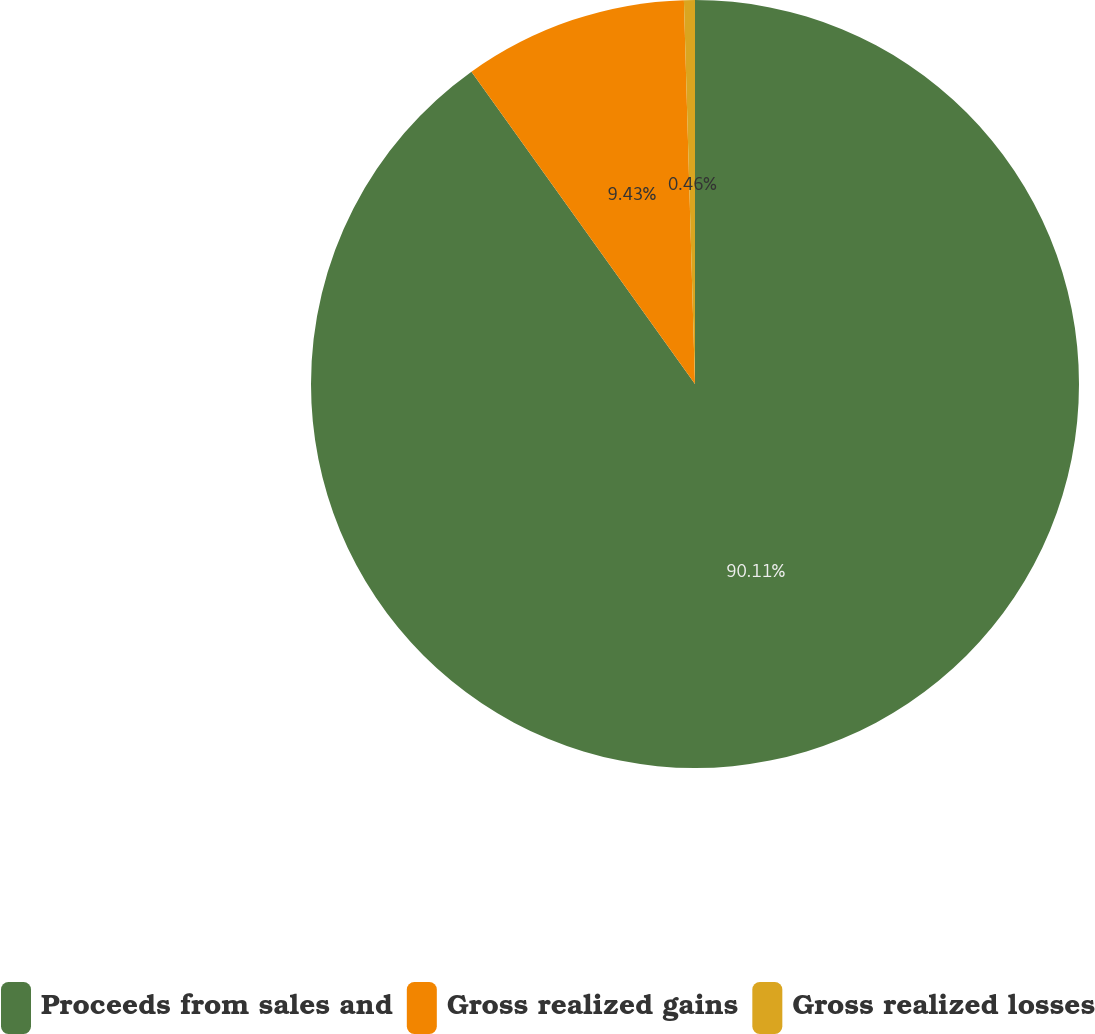Convert chart to OTSL. <chart><loc_0><loc_0><loc_500><loc_500><pie_chart><fcel>Proceeds from sales and<fcel>Gross realized gains<fcel>Gross realized losses<nl><fcel>90.11%<fcel>9.43%<fcel>0.46%<nl></chart> 